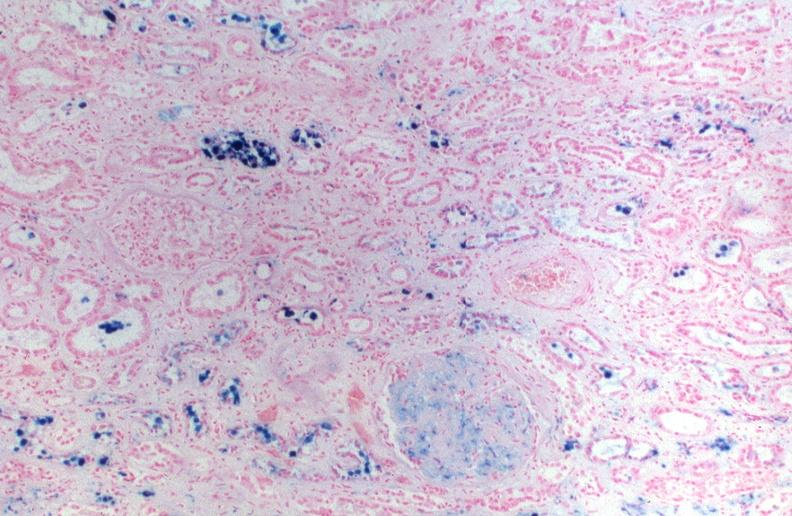what does this image show?
Answer the question using a single word or phrase. Kidney 